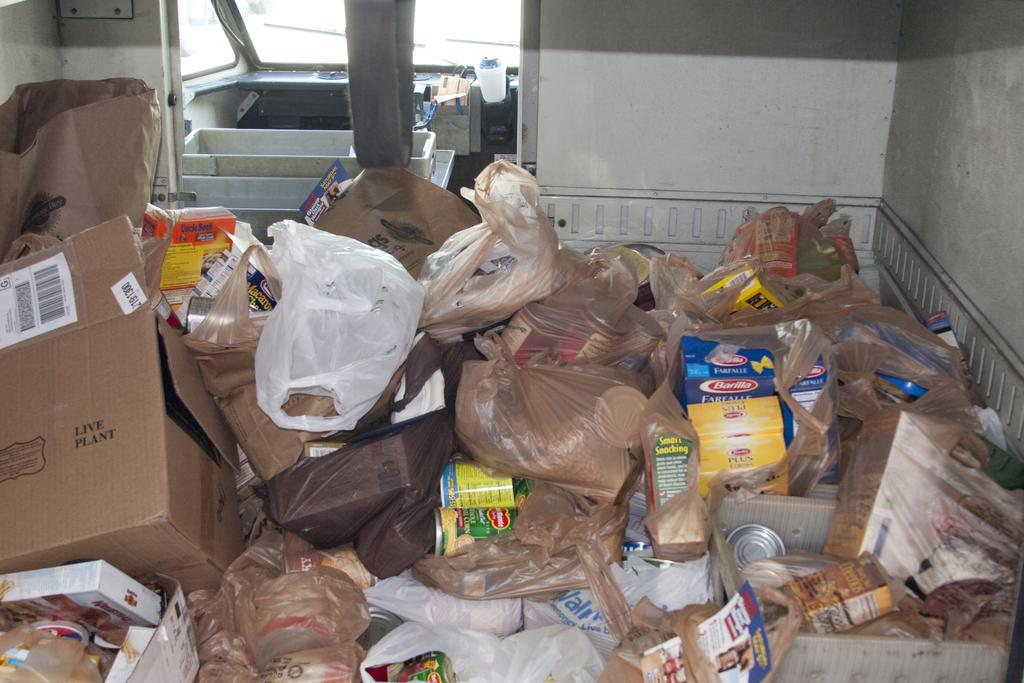What type of containers are present in the image? There are cardboard boxes, covers, and tins in the image. What else can be seen in the image besides containers? There appears to be a vehicle in the background of the image. Can you describe the objects visible in the image? There are objects visible in the image, but their specific nature is not mentioned in the provided facts. Where is the giraffe standing in the image? There is no giraffe present in the image. What type of pickle is being used to hold the tins in the image? There is no pickle present in the image; the tins are held by other means. 